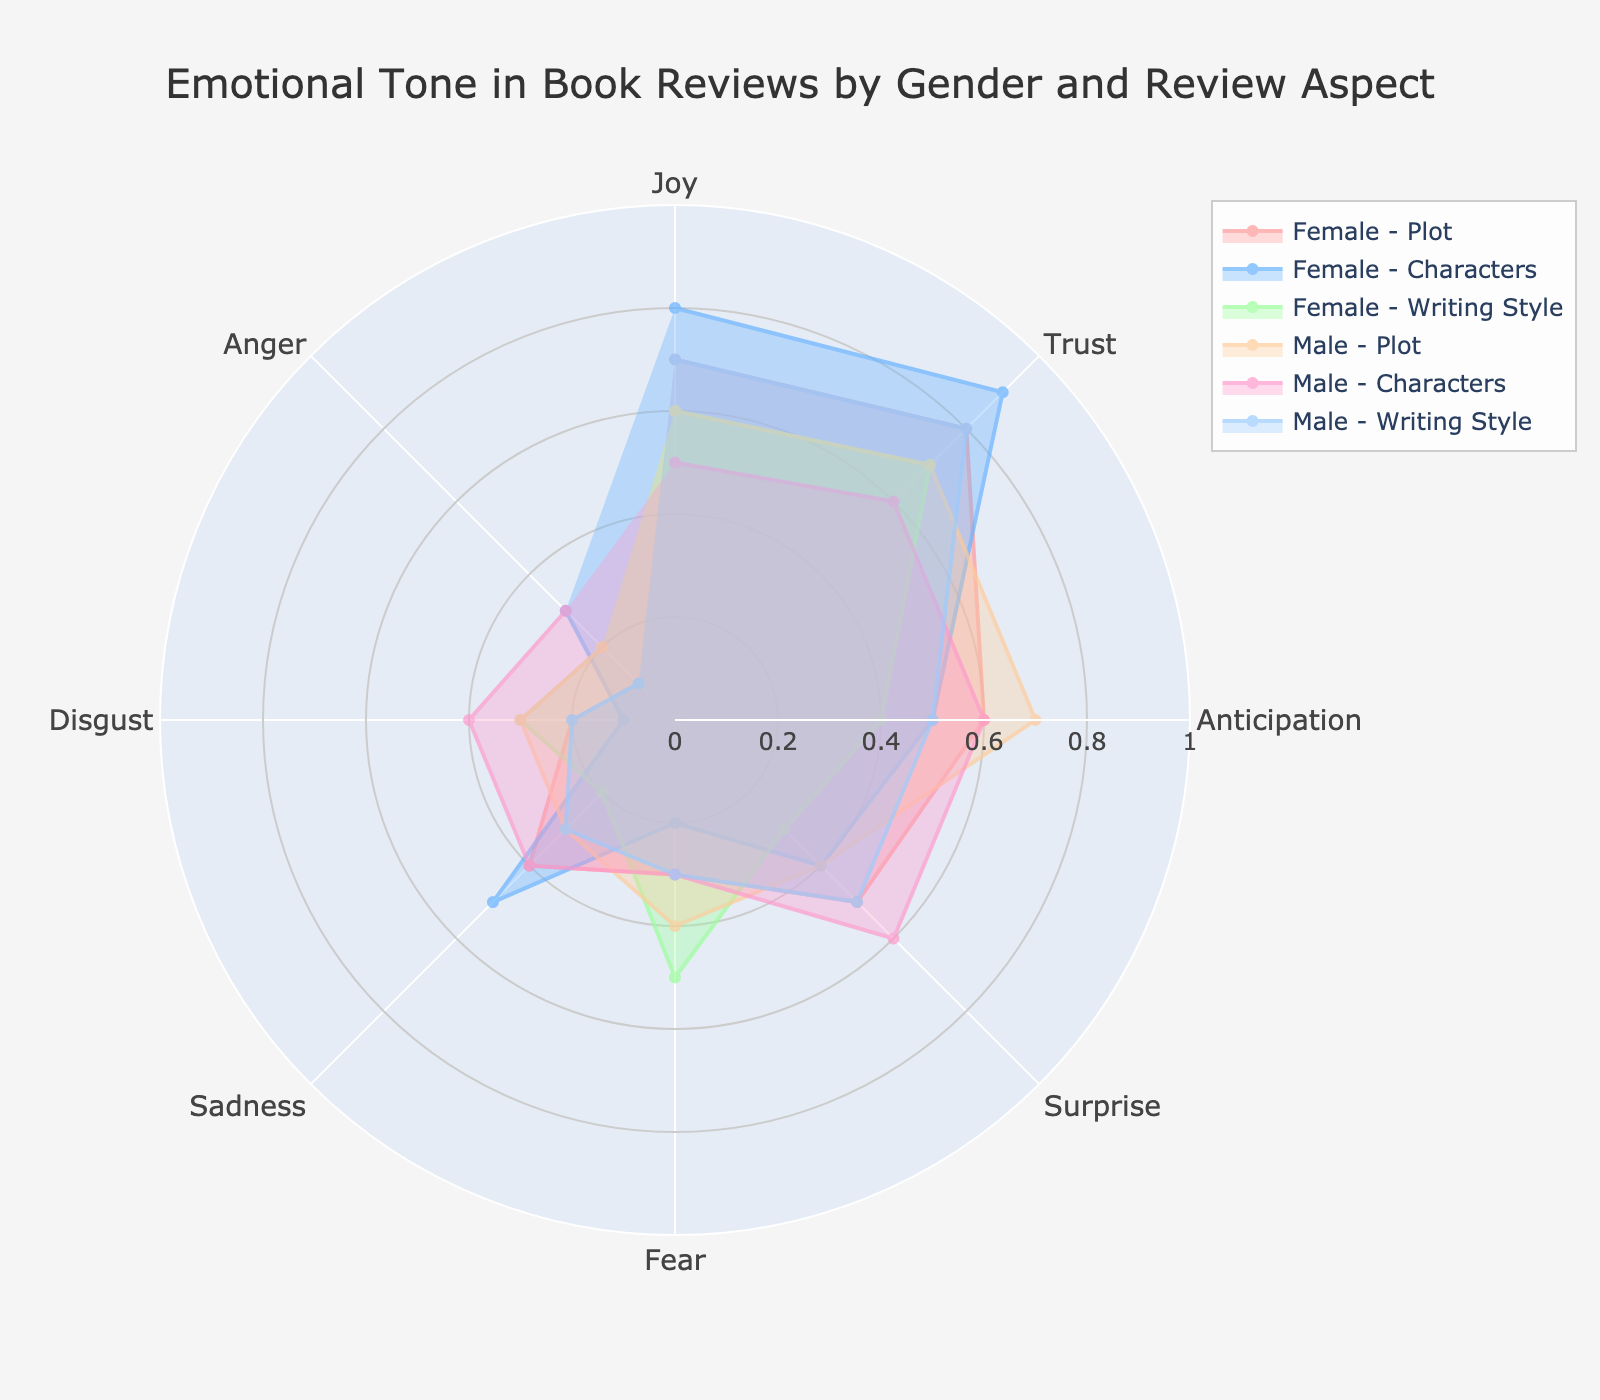How many different emotional tones are displayed in the chart? There are labels along the polar axis for each emotional tone. Counting them, we see Joy, Trust, Anticipation, Surprise, Fear, Sadness, Disgust, and Anger.
Answer: 8 Which gender group's review on "Characters" demonstrates the highest level of trust? Look for the data corresponding to "Characters" for both Female and Male groups and compare the trust levels. Female reviews on "Characters" have a trust level of 0.9, while Male reviews have 0.6.
Answer: Female What's the average level of joy expressed in reviews for the "Writing Style" aspect across both gender groups? Add the joy levels for both Female (0.6) and Male (0.7) reviews of "Writing Style" and divide by 2. The calculation is (0.6 + 0.7) / 2 = 0.65.
Answer: 0.65 Which emotional tone shows the largest difference between Female and Male reviews on the "Plot" aspect? Calculate the absolute differences for each emotional tone between Female and Male reviews of the "Plot" aspect and identify the largest difference. The differences are Joy (0.1), Trust (0.1), Anticipation (0.1), Surprise (0.1), Fear (0.1), Sadness (0.1), Disgust (0.1), Anger (0.1). All differences are equal, indicating no singled-out largest difference.
Answer: Equal across all tones In which review aspect do Female reviews express the highest level of sadness? Compare the sadness levels for Female reviews across all aspects (Plot, Characters, Writing Style). Sadness levels for these aspects are 0.4 (Plot), 0.5 (Characters), 0.2 (Writing Style). The highest is for "Characters".
Answer: Characters How does the distribution of anticipation differ between Female and Male reviews on the "Plot" aspect? Compare the anticipation levels for Female (0.6) and Male (0.7) reviews on "Plot". The Female reviews have slightly lower anticipation.
Answer: Male reviews show higher anticipation What is the average trust level expressed by Male reviewers across all aspects (Plot, Characters, Writing Style)? Add the trust levels for Male reviews on "Plot" (0.7), "Characters" (0.6), and "Writing Style" (0.8) and divide by 3. The calculation is (0.7 + 0.6 + 0.8) / 3 = 0.7.
Answer: 0.7 Which gender group has a more consistent expression of the emotion "Anger" across different review aspects? Compare the levels of Anger across different aspects for both gender groups. Female: 0.1 (Plot), 0.3 (Characters), 0.2 (Writing Style). Male: 0.2 (Plot), 0.3 (Characters), 0.1 (Writing Style). Female reviews are closer in values.
Answer: Female 